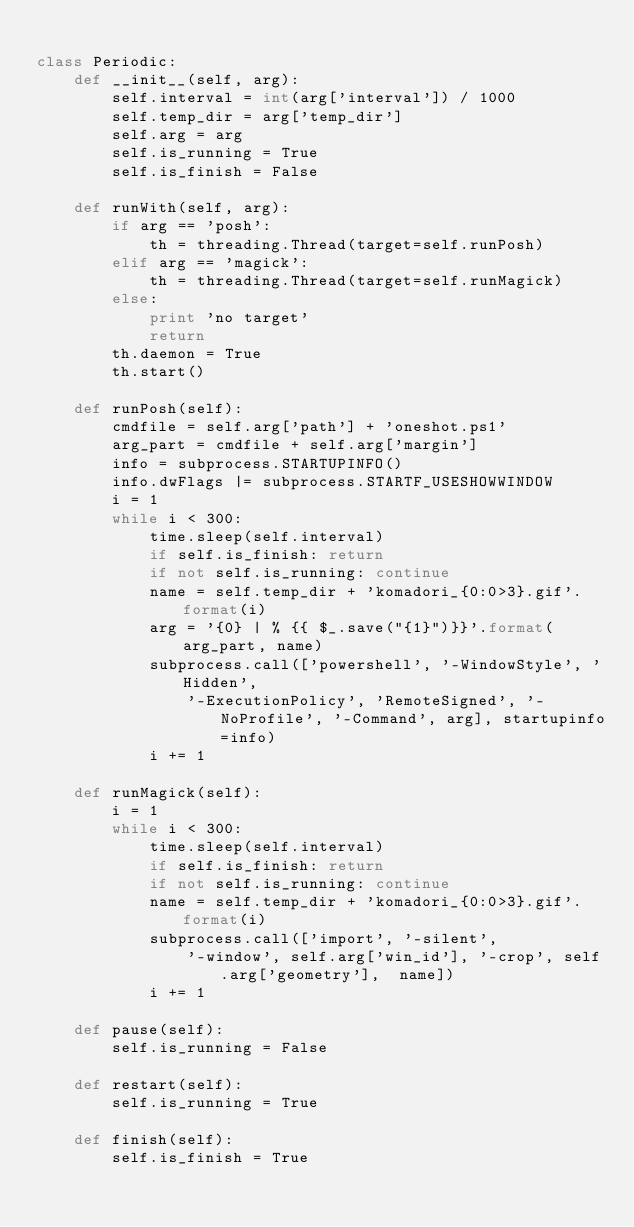Convert code to text. <code><loc_0><loc_0><loc_500><loc_500><_Python_>
class Periodic:
    def __init__(self, arg):
        self.interval = int(arg['interval']) / 1000
        self.temp_dir = arg['temp_dir']
        self.arg = arg
        self.is_running = True
        self.is_finish = False

    def runWith(self, arg):
        if arg == 'posh':
            th = threading.Thread(target=self.runPosh)
        elif arg == 'magick':
            th = threading.Thread(target=self.runMagick)
        else:
            print 'no target'
            return
        th.daemon = True
        th.start()

    def runPosh(self):
        cmdfile = self.arg['path'] + 'oneshot.ps1'
        arg_part = cmdfile + self.arg['margin']
        info = subprocess.STARTUPINFO()
        info.dwFlags |= subprocess.STARTF_USESHOWWINDOW
        i = 1
        while i < 300:
            time.sleep(self.interval)
            if self.is_finish: return
            if not self.is_running: continue
            name = self.temp_dir + 'komadori_{0:0>3}.gif'.format(i)
            arg = '{0} | % {{ $_.save("{1}")}}'.format(arg_part, name)
            subprocess.call(['powershell', '-WindowStyle', 'Hidden',
                '-ExecutionPolicy', 'RemoteSigned', '-NoProfile', '-Command', arg], startupinfo=info)
            i += 1

    def runMagick(self):
        i = 1
        while i < 300:
            time.sleep(self.interval)
            if self.is_finish: return
            if not self.is_running: continue
            name = self.temp_dir + 'komadori_{0:0>3}.gif'.format(i)
            subprocess.call(['import', '-silent',
                '-window', self.arg['win_id'], '-crop', self.arg['geometry'],  name])
            i += 1

    def pause(self):
        self.is_running = False

    def restart(self):
        self.is_running = True

    def finish(self):
        self.is_finish = True


</code> 